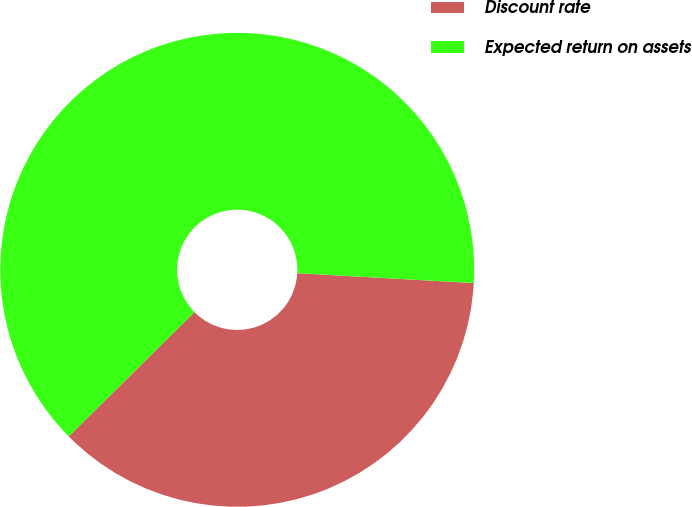Convert chart to OTSL. <chart><loc_0><loc_0><loc_500><loc_500><pie_chart><fcel>Discount rate<fcel>Expected return on assets<nl><fcel>36.7%<fcel>63.3%<nl></chart> 